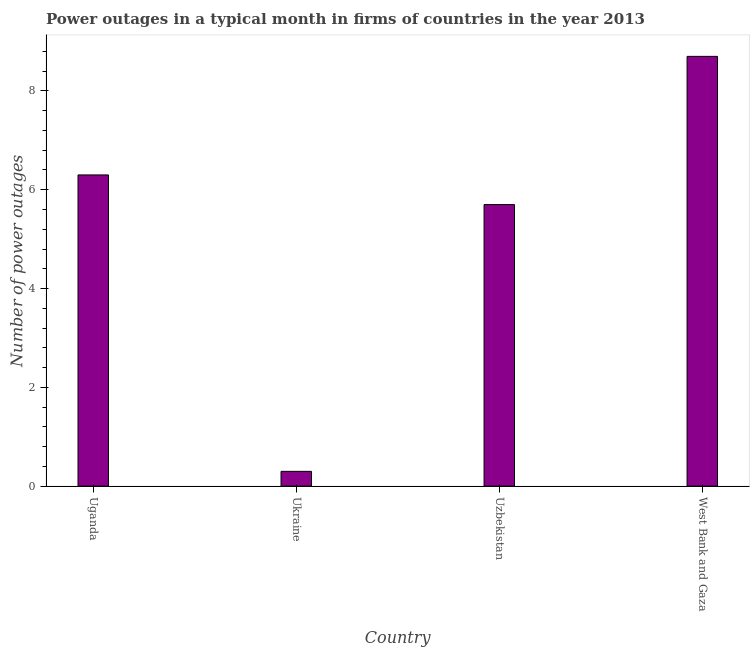Does the graph contain any zero values?
Offer a terse response. No. Does the graph contain grids?
Your answer should be compact. No. What is the title of the graph?
Offer a terse response. Power outages in a typical month in firms of countries in the year 2013. What is the label or title of the X-axis?
Your answer should be compact. Country. What is the label or title of the Y-axis?
Your answer should be very brief. Number of power outages. What is the number of power outages in West Bank and Gaza?
Your answer should be very brief. 8.7. In which country was the number of power outages maximum?
Offer a terse response. West Bank and Gaza. In which country was the number of power outages minimum?
Keep it short and to the point. Ukraine. What is the sum of the number of power outages?
Your response must be concise. 21. What is the average number of power outages per country?
Your answer should be very brief. 5.25. What is the median number of power outages?
Give a very brief answer. 6. What is the ratio of the number of power outages in Uganda to that in West Bank and Gaza?
Make the answer very short. 0.72. What is the difference between the highest and the second highest number of power outages?
Give a very brief answer. 2.4. In how many countries, is the number of power outages greater than the average number of power outages taken over all countries?
Your answer should be very brief. 3. What is the difference between two consecutive major ticks on the Y-axis?
Offer a terse response. 2. Are the values on the major ticks of Y-axis written in scientific E-notation?
Provide a succinct answer. No. What is the Number of power outages of Uzbekistan?
Make the answer very short. 5.7. What is the difference between the Number of power outages in Uganda and Ukraine?
Ensure brevity in your answer.  6. What is the difference between the Number of power outages in Uganda and Uzbekistan?
Provide a succinct answer. 0.6. What is the difference between the Number of power outages in Uganda and West Bank and Gaza?
Provide a succinct answer. -2.4. What is the difference between the Number of power outages in Ukraine and Uzbekistan?
Offer a very short reply. -5.4. What is the difference between the Number of power outages in Ukraine and West Bank and Gaza?
Give a very brief answer. -8.4. What is the ratio of the Number of power outages in Uganda to that in Uzbekistan?
Your response must be concise. 1.1. What is the ratio of the Number of power outages in Uganda to that in West Bank and Gaza?
Your answer should be compact. 0.72. What is the ratio of the Number of power outages in Ukraine to that in Uzbekistan?
Give a very brief answer. 0.05. What is the ratio of the Number of power outages in Ukraine to that in West Bank and Gaza?
Provide a short and direct response. 0.03. What is the ratio of the Number of power outages in Uzbekistan to that in West Bank and Gaza?
Your answer should be very brief. 0.66. 